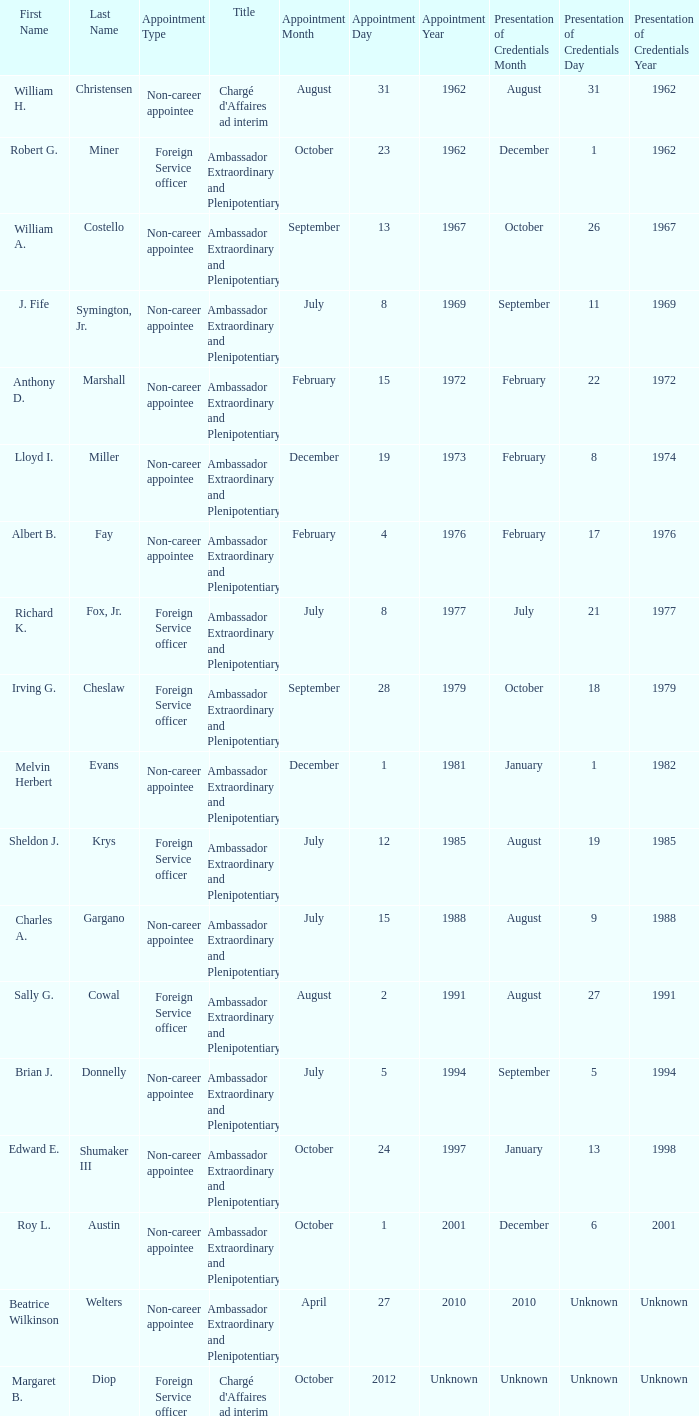When did Robert G. Miner present his credentials? December 1, 1962. 